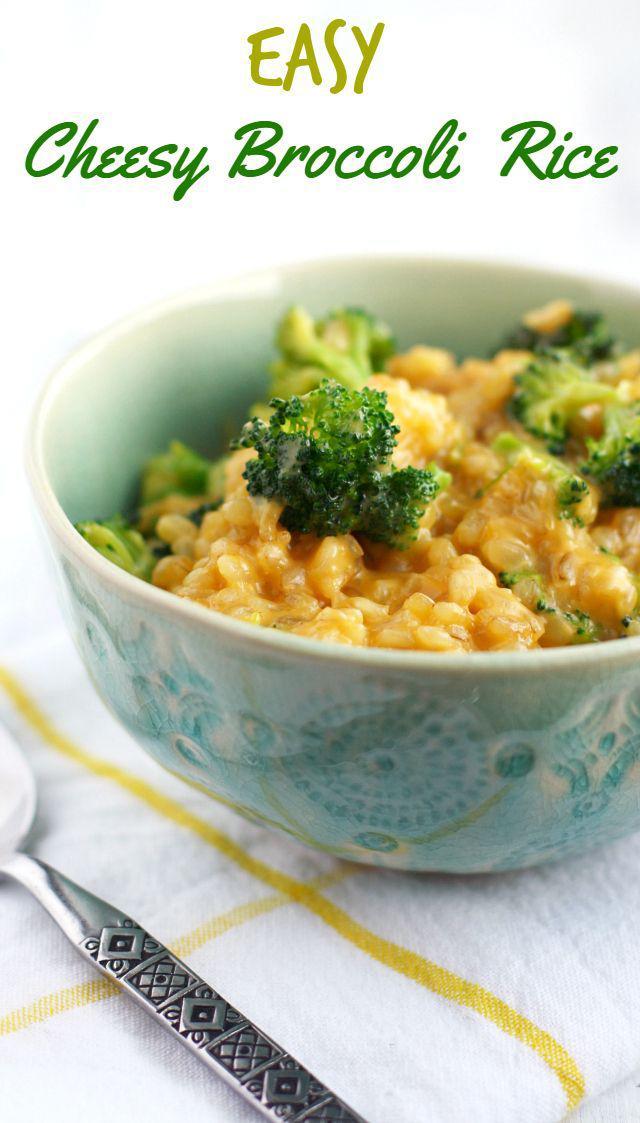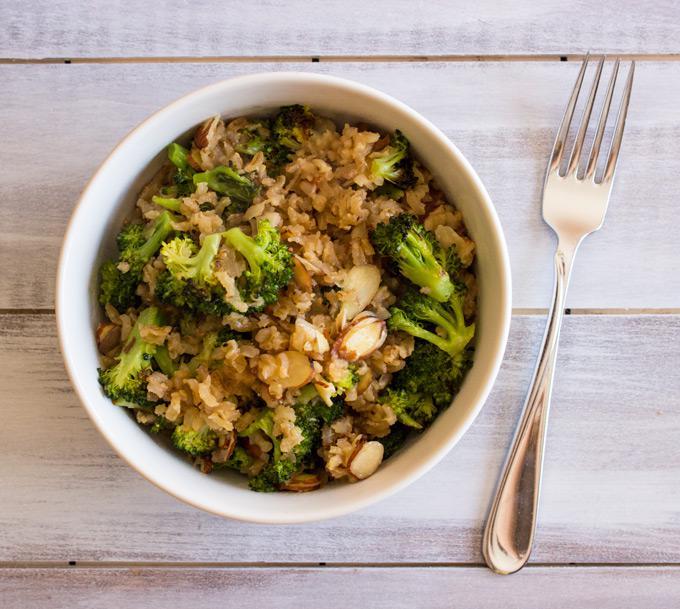The first image is the image on the left, the second image is the image on the right. Considering the images on both sides, is "There is at least one fork clearly visible." valid? Answer yes or no. Yes. 